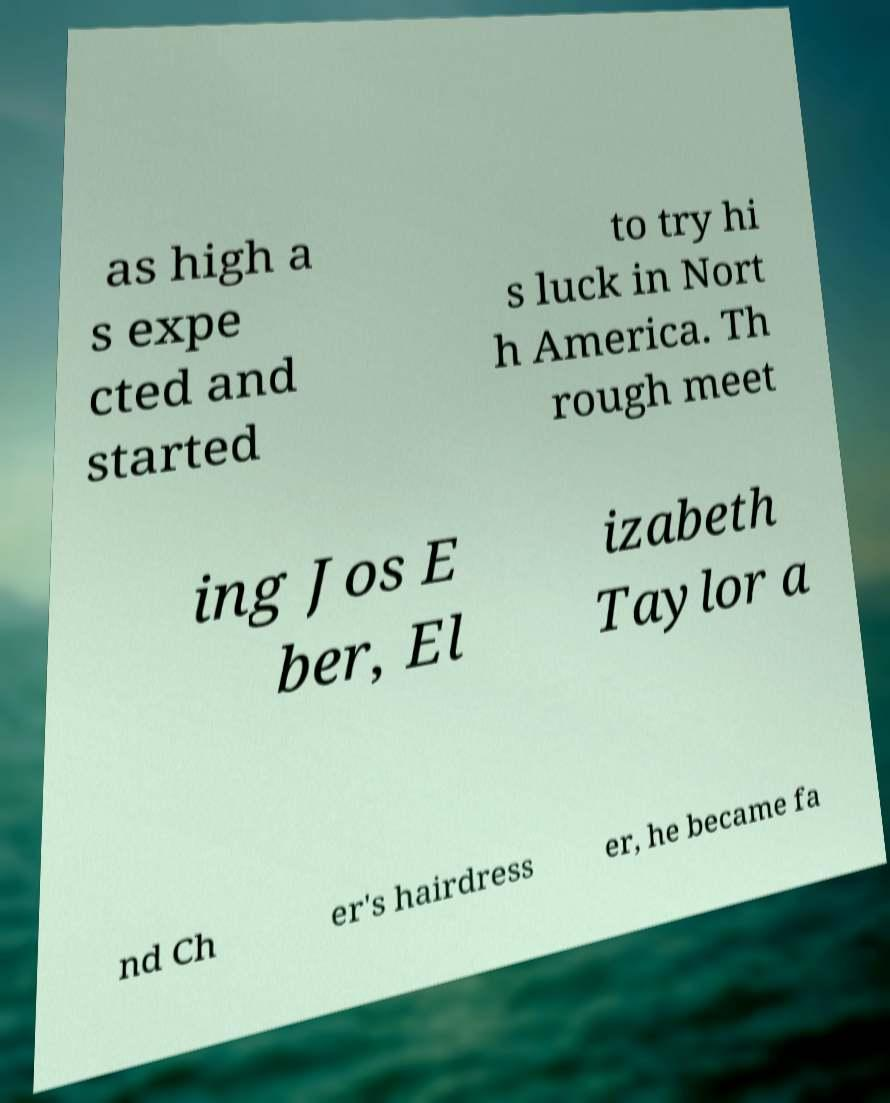Can you accurately transcribe the text from the provided image for me? as high a s expe cted and started to try hi s luck in Nort h America. Th rough meet ing Jos E ber, El izabeth Taylor a nd Ch er's hairdress er, he became fa 